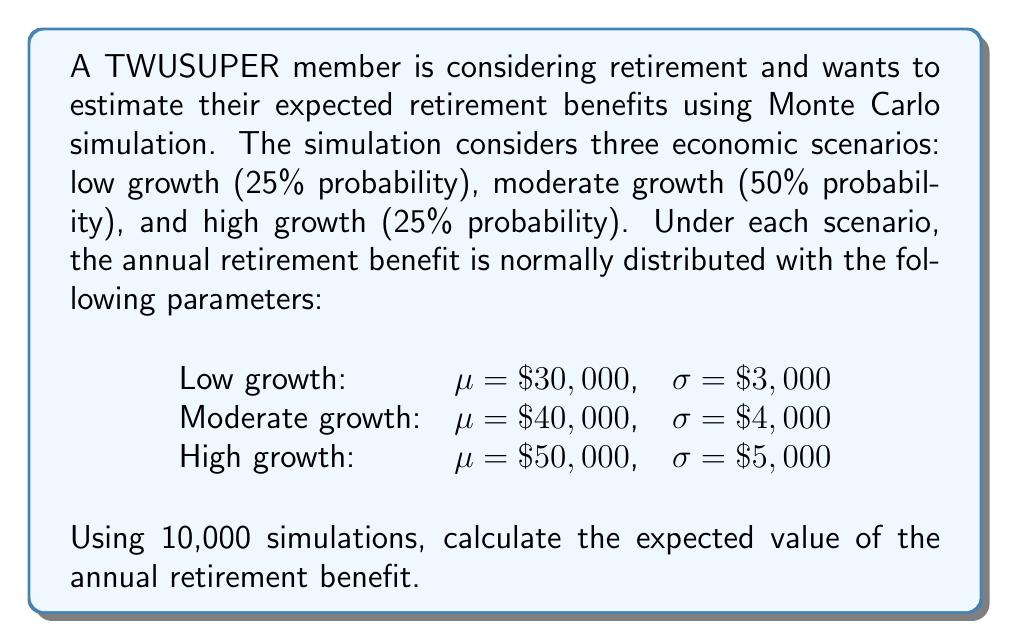Can you solve this math problem? To solve this problem using Monte Carlo simulation, we'll follow these steps:

1) First, we need to generate 10,000 random scenarios based on the given probabilities:
   - 2,500 for low growth (25%)
   - 5,000 for moderate growth (50%)
   - 2,500 for high growth (25%)

2) For each scenario, we'll generate a random annual benefit from the corresponding normal distribution:
   - Low growth: $X \sim N(30000, 3000^2)$
   - Moderate growth: $Y \sim N(40000, 4000^2)$
   - High growth: $Z \sim N(50000, 5000^2)$

3) We'll sum up all these random benefits and divide by 10,000 to get the expected value.

Let's represent this mathematically:

$$E[Benefit] = \frac{1}{10000} \left(\sum_{i=1}^{2500} X_i + \sum_{j=1}^{5000} Y_j + \sum_{k=1}^{2500} Z_k\right)$$

Where $X_i$, $Y_j$, and $Z_k$ are random samples from their respective distributions.

4) In practice, we would use a computer to perform this simulation. However, we can calculate the theoretical expected value:

$$E[Benefit] = 0.25 \cdot 30000 + 0.50 \cdot 40000 + 0.25 \cdot 50000 = 40000$$

5) The Monte Carlo simulation should converge to this theoretical value as the number of simulations increases.

6) The standard error of the Monte Carlo estimate can be calculated as:

$$SE = \sqrt{\frac{0.25 \cdot 3000^2 + 0.50 \cdot 4000^2 + 0.25 \cdot 5000^2}{10000}} \approx 39.05$$

So, we would expect our Monte Carlo estimate to be within about $\pm 78$ (two standard errors) of the true value of $40,000 with 95% confidence.
Answer: $40,000 ± 78 (95% CI) 